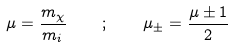<formula> <loc_0><loc_0><loc_500><loc_500>\mu = \frac { m _ { \chi } } { m _ { i } } \quad ; \quad \mu _ { \pm } = \frac { \mu \pm 1 } { 2 }</formula> 